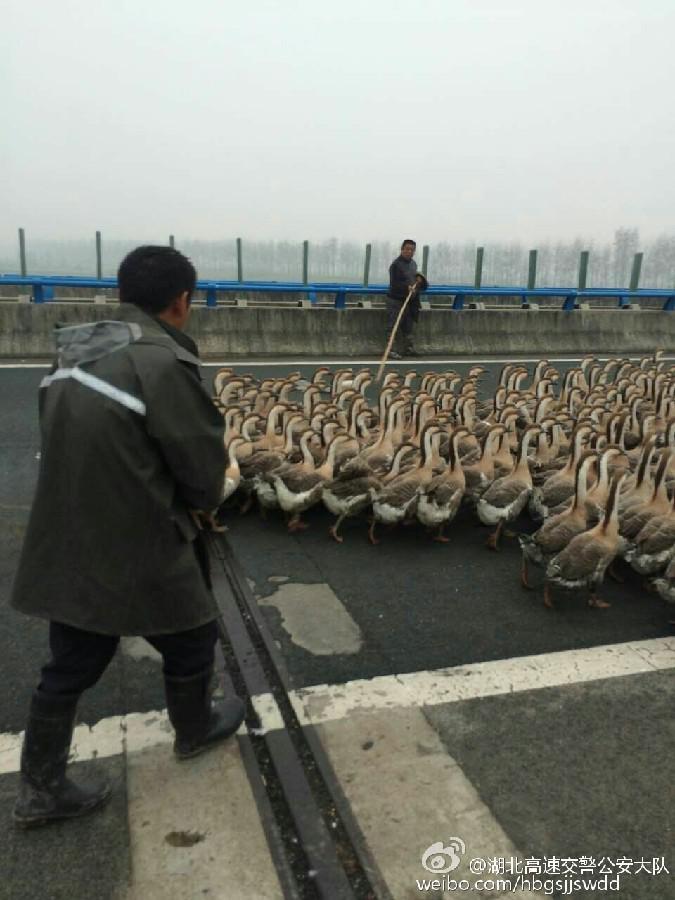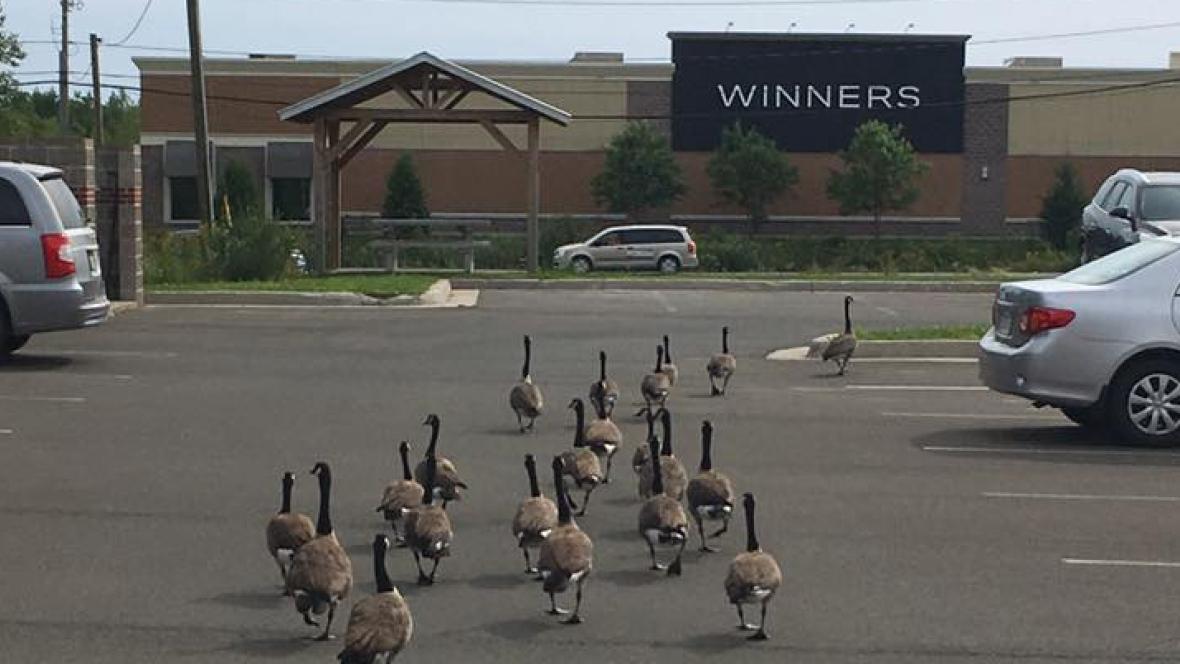The first image is the image on the left, the second image is the image on the right. Assess this claim about the two images: "An image contains a person facing a large group of ducks,". Correct or not? Answer yes or no. Yes. The first image is the image on the left, the second image is the image on the right. Examine the images to the left and right. Is the description "A man holding a stick is along the side of a road filled with walking geese, and another man is in the foreground behind the geese." accurate? Answer yes or no. Yes. 